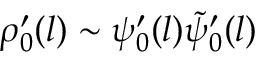<formula> <loc_0><loc_0><loc_500><loc_500>\rho _ { 0 } ^ { \prime } ( l ) \sim \psi _ { 0 } ^ { \prime } ( l ) \tilde { \psi } _ { 0 } ^ { \prime } ( l )</formula> 